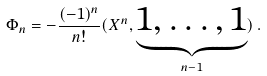<formula> <loc_0><loc_0><loc_500><loc_500>\Phi _ { n } = - \frac { ( - 1 ) ^ { n } } { n ! } ( X ^ { n } , \underbrace { 1 , \dots , 1 } _ { n - 1 } ) \, .</formula> 